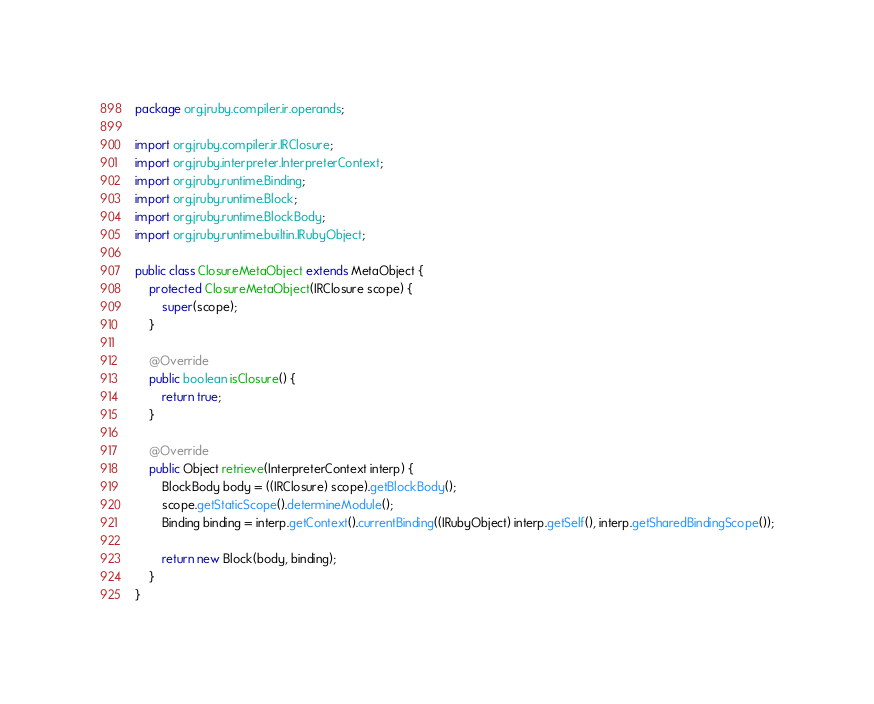<code> <loc_0><loc_0><loc_500><loc_500><_Java_>package org.jruby.compiler.ir.operands;

import org.jruby.compiler.ir.IRClosure;
import org.jruby.interpreter.InterpreterContext;
import org.jruby.runtime.Binding;
import org.jruby.runtime.Block;
import org.jruby.runtime.BlockBody;
import org.jruby.runtime.builtin.IRubyObject;

public class ClosureMetaObject extends MetaObject {
    protected ClosureMetaObject(IRClosure scope) {
        super(scope);
    }

    @Override
    public boolean isClosure() {
        return true;
    }

    @Override
    public Object retrieve(InterpreterContext interp) {
        BlockBody body = ((IRClosure) scope).getBlockBody();
        scope.getStaticScope().determineModule();
        Binding binding = interp.getContext().currentBinding((IRubyObject) interp.getSelf(), interp.getSharedBindingScope());

        return new Block(body, binding);
    }
}
</code> 